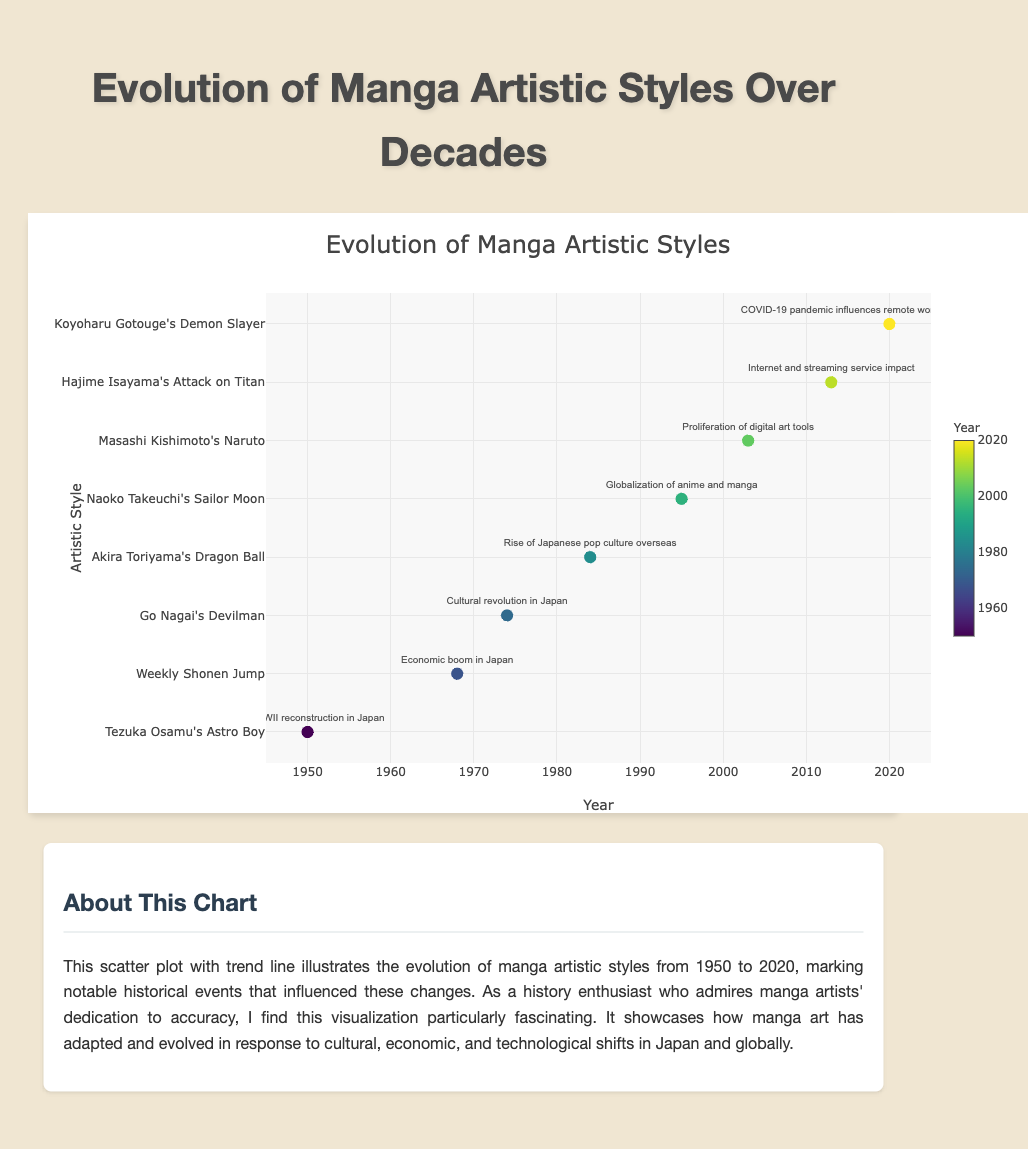What's the title of the chart? The title is mentioned at the top of the chart, which provides an indication of what the data visualization is about.
Answer: Evolution of Manga Artistic Styles What is the time range covered by the data points in the chart? By observing the x-axis labeled "Year," the data points range from the earliest year on the axis to the latest year on the axis.
Answer: 1950 to 2020 How many notable events are highlighted in the chart? Each data point represents a notable event in a specific year, so counting the number of data points will give the total count of notable events. There are eight data points in the chart.
Answer: 8 Which event is linked to the introduction of digital art tools in manga creation? By checking the data labels associated with each data point, we find that the year 2003 (Masashi Kishimoto's Naruto) corresponds to the proliferation of digital art tools.
Answer: 2003, Masashi Kishimoto's Naruto Comparing the years 1984 and 1995, how did the artistic styles evolve? The 1984 artistic style (Akira Toriyama's Dragon Ball) features bold lines and exaggerated expressions, focusing on movement. By 1995, the style (Naoko Takeuchi's Sailor Moon) evolved to elegant, elongated forms with intricate costume designs.
Answer: From bold lines and exaggerated expressions to elegant, elongated forms with intricate costume designs What impact did the COVID-19 pandemic have on manga artistic styles? Looking at the data point for 2020 (Koyoharu Gotouge's Demon Slayer), the COVID-19 pandemic influenced remote work and digital distribution, leading to art that blends traditional and modern techniques, with a focus on fluid animation-inspired designs.
Answer: Remote work and digital distribution, blending traditional and modern techniques Which year witnessed Japan's economic boom and how did it influence manga artistic styles? Referring to the data labels, the economic boom in Japan is associated with the year 1968 (Weekly Shonen Jump), influencing manga with dynamic action sequences and detailed backgrounds.
Answer: 1968, dynamic action sequences, and detailed backgrounds What are the common artistic influences observed in manga styles during the 2000s (2000-2020)? Analyzing the artistic influences for the years 2003 (Masashi Kishimoto's Naruto) and 2013 (Hajime Isayama's Attack on Titan), common themes include the refinement of character designs using a mix of traditional and digital techniques, as well as gritty, detailed art with unique panel compositions.
Answer: Refined character designs, mix of traditional and digital techniques, gritty detailed art What significant change in manga art style is observed in response to globalization in 1995? The 1995 data point (Naoko Takeuchi's Sailor Moon) shows that globalization of anime and manga led to more elegant, elongated forms and intricate costume designs in artistic styles. This marked a shift towards more detailed and sophisticated character designs.
Answer: Elegant, elongated forms, intricate costume designs 